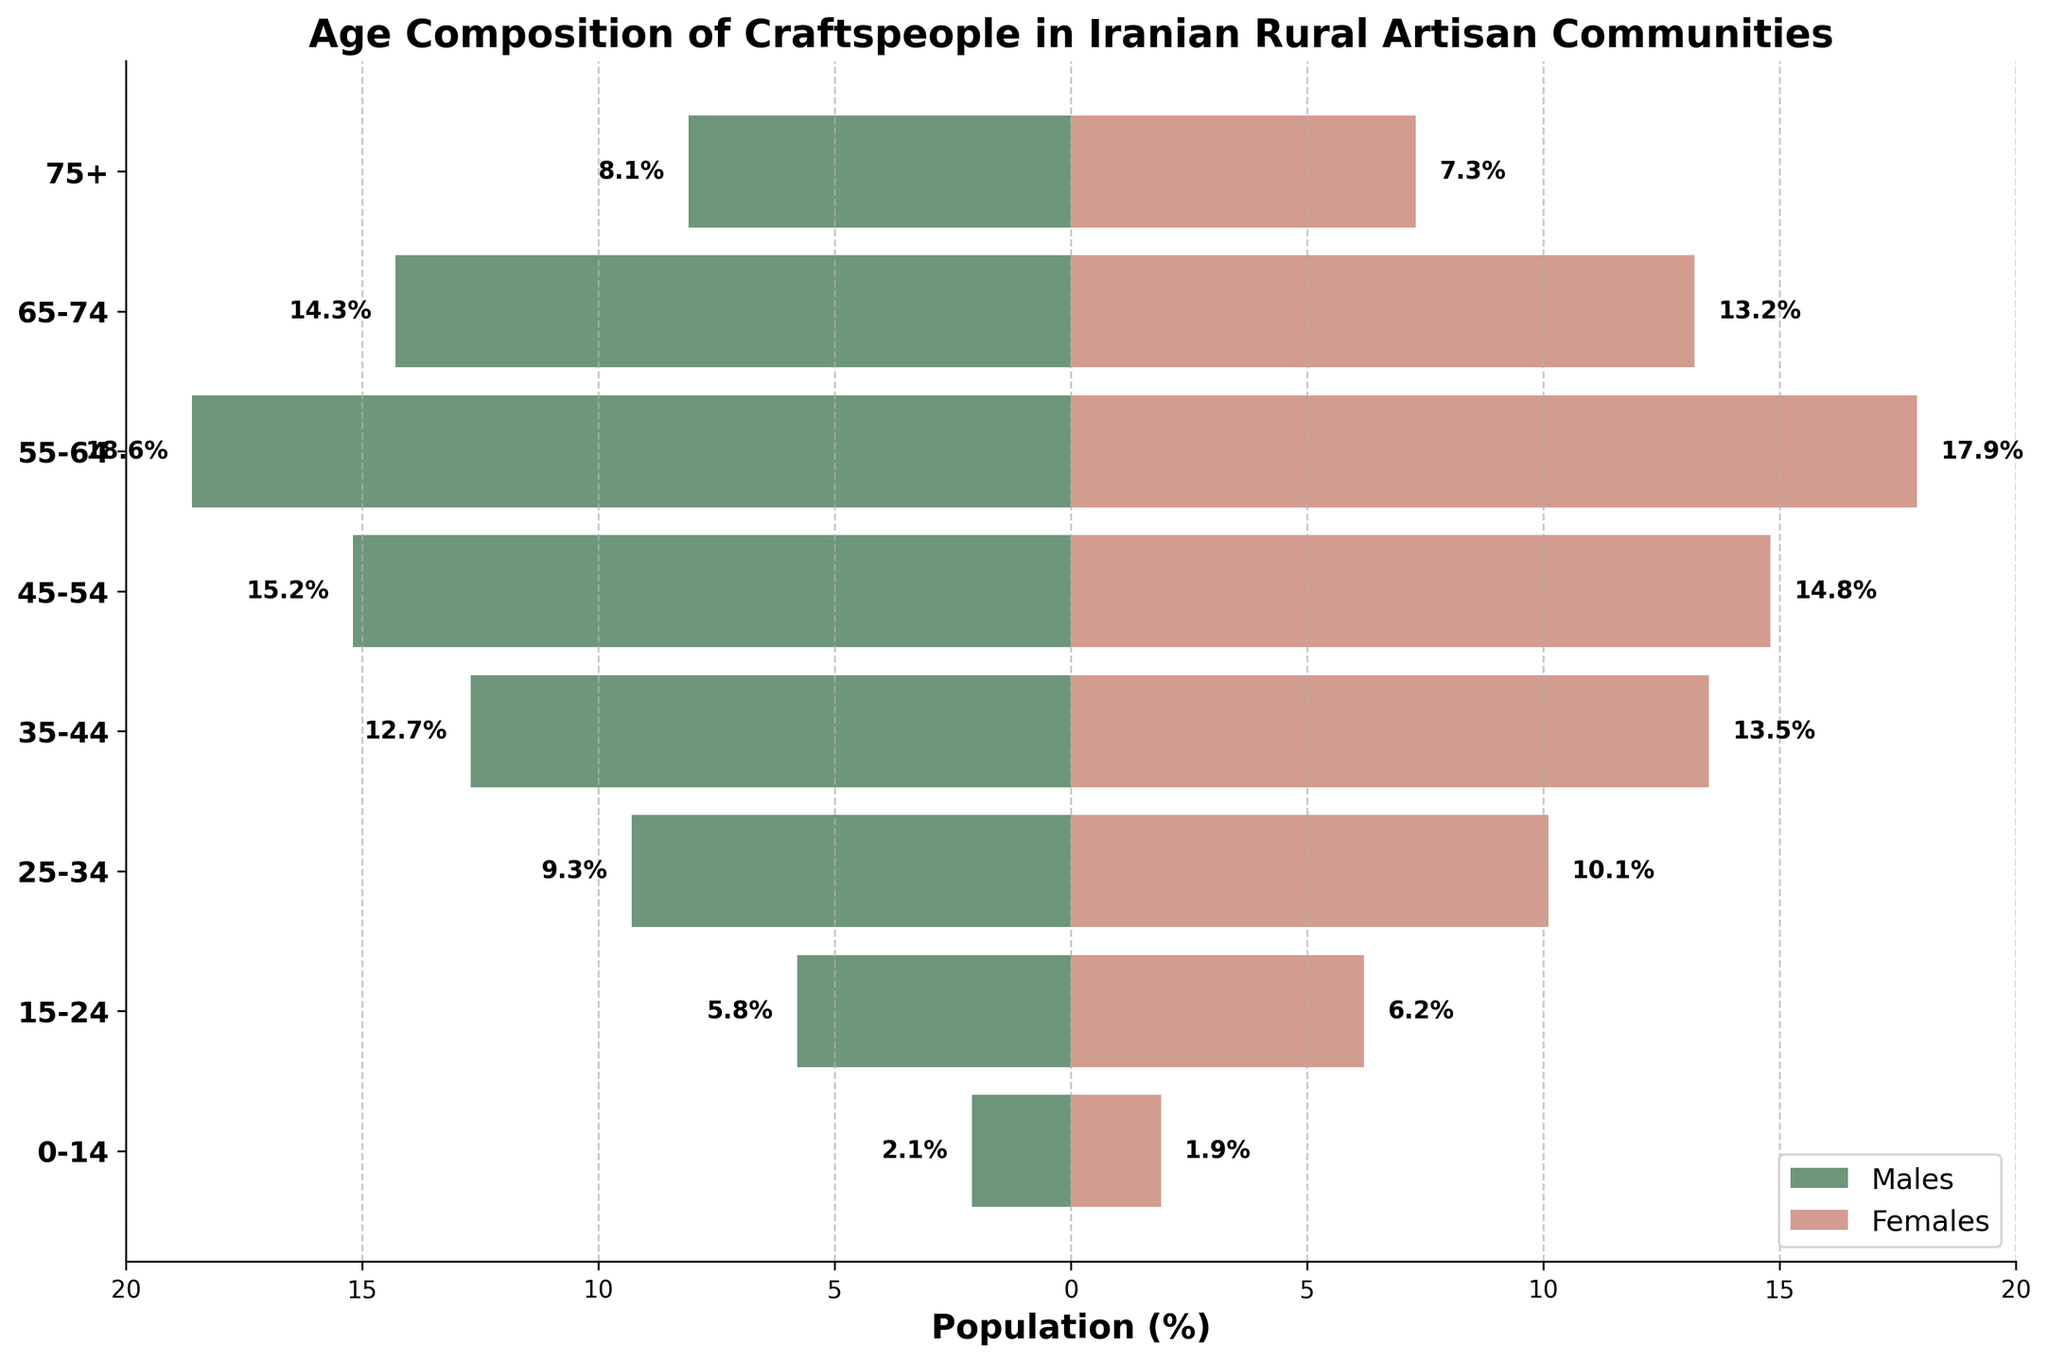What is the age range with the highest percentage of female craftspeople? The bar representing the age range 35-44 on the right (females) is the tallest, indicating the highest percentage.
Answer: 35-44 Which age group has a higher percentage of male craftspeople compared to female craftspeople? The left and right bars for each age range are compared. The age range 75+ has males (8.1) greater than females (7.3).
Answer: 75+ Which age range exhibits the greatest parity between male and female craftspeople percentages? By examining the bars, the age range 55-64 shows males (18.6) and females (17.9) with a small difference of 0.7%.
Answer: 55-64 What is the total percentage of craftspeople for the age range 25-34? Sum the percentages of males (9.3) and females (10.1) for the age range 25-34.
Answer: 19.4% Which side of the pyramid typically has taller bars: males or females? Observing the general trend across all bars, it is noticed that the females’ bars appear taller, especially clearly in the mid age ranges.
Answer: Females Is the percentage of craftspeople aged 45-54 greater than those aged 0-14 for both males and females? Comparing the bars directly, males 45-54 (15.2) is greater than 0-14 (2.1) and females 45-54 (14.8) is greater than 0-14 (1.9).
Answer: Yes What can be inferred about the age distribution of craftspeople from the way the pyramid is shaped? The pyramid is wider in the middle age ranges (35-64) and narrows at both ends, suggesting more craftspeople are in their mid to late careers.
Answer: Concentrated in middle age ranges How does the percentage of female craftspeople in the age range 65-74 compare to the percentage of male craftspeople aged 25-34? For females aged 65-74 it is 13.2%, and for males aged 25-34 it is 9.3%.
Answer: 65-74 females have a higher percentage What is the difference in percentage between males and females in the age range 35-44? Subtract the percentage of males (12.7) from females (13.5).
Answer: 0.8% How many age ranges have more than 10% of the population for both males and females? Identifying the bars where both male and female percentages are above 10%, which are 35-44, 45-54, and 55-64.
Answer: 3 